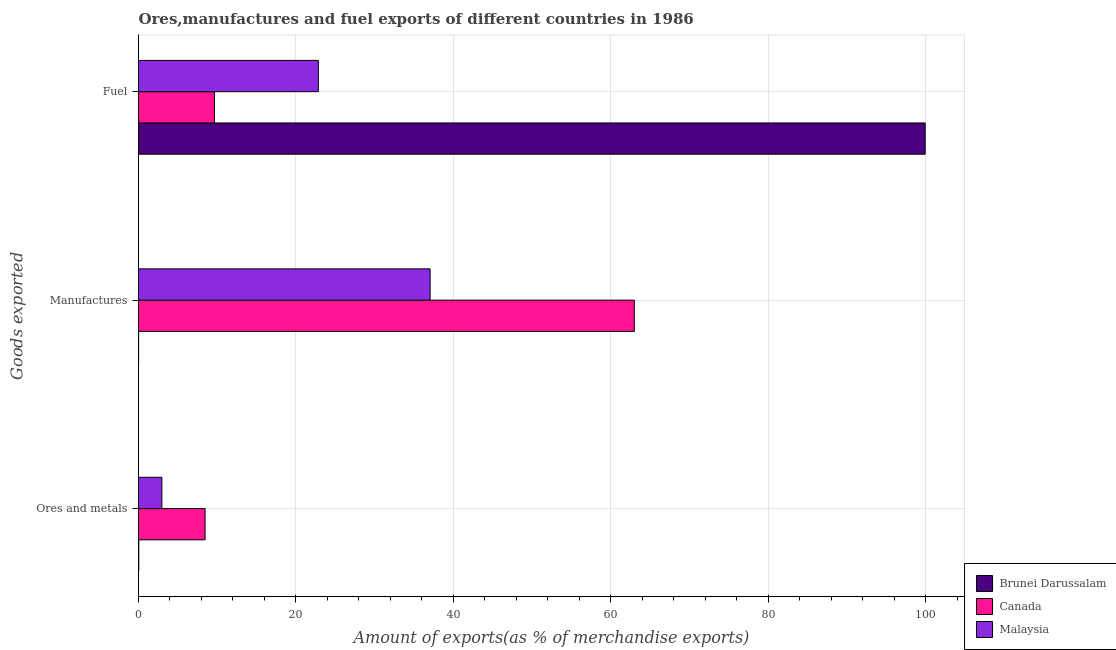How many different coloured bars are there?
Provide a short and direct response. 3. How many groups of bars are there?
Your answer should be very brief. 3. Are the number of bars on each tick of the Y-axis equal?
Your response must be concise. Yes. How many bars are there on the 1st tick from the bottom?
Provide a short and direct response. 3. What is the label of the 1st group of bars from the top?
Give a very brief answer. Fuel. What is the percentage of manufactures exports in Malaysia?
Your answer should be compact. 37.05. Across all countries, what is the maximum percentage of fuel exports?
Ensure brevity in your answer.  99.95. Across all countries, what is the minimum percentage of manufactures exports?
Make the answer very short. 0.01. In which country was the percentage of manufactures exports minimum?
Give a very brief answer. Brunei Darussalam. What is the total percentage of ores and metals exports in the graph?
Offer a very short reply. 11.46. What is the difference between the percentage of fuel exports in Brunei Darussalam and that in Canada?
Provide a short and direct response. 90.29. What is the difference between the percentage of manufactures exports in Canada and the percentage of fuel exports in Brunei Darussalam?
Ensure brevity in your answer.  -36.95. What is the average percentage of fuel exports per country?
Provide a succinct answer. 44.15. What is the difference between the percentage of fuel exports and percentage of manufactures exports in Brunei Darussalam?
Your answer should be compact. 99.93. In how many countries, is the percentage of manufactures exports greater than 88 %?
Keep it short and to the point. 0. What is the ratio of the percentage of manufactures exports in Brunei Darussalam to that in Canada?
Your response must be concise. 0. Is the percentage of fuel exports in Malaysia less than that in Canada?
Make the answer very short. No. Is the difference between the percentage of manufactures exports in Brunei Darussalam and Malaysia greater than the difference between the percentage of fuel exports in Brunei Darussalam and Malaysia?
Make the answer very short. No. What is the difference between the highest and the second highest percentage of fuel exports?
Offer a very short reply. 77.1. What is the difference between the highest and the lowest percentage of ores and metals exports?
Provide a short and direct response. 8.42. In how many countries, is the percentage of fuel exports greater than the average percentage of fuel exports taken over all countries?
Provide a succinct answer. 1. What does the 3rd bar from the bottom in Ores and metals represents?
Offer a very short reply. Malaysia. How many bars are there?
Ensure brevity in your answer.  9. How many countries are there in the graph?
Ensure brevity in your answer.  3. What is the difference between two consecutive major ticks on the X-axis?
Your response must be concise. 20. Where does the legend appear in the graph?
Your response must be concise. Bottom right. How many legend labels are there?
Provide a succinct answer. 3. How are the legend labels stacked?
Your response must be concise. Vertical. What is the title of the graph?
Provide a succinct answer. Ores,manufactures and fuel exports of different countries in 1986. Does "Hong Kong" appear as one of the legend labels in the graph?
Your answer should be very brief. No. What is the label or title of the X-axis?
Provide a short and direct response. Amount of exports(as % of merchandise exports). What is the label or title of the Y-axis?
Your answer should be very brief. Goods exported. What is the Amount of exports(as % of merchandise exports) of Brunei Darussalam in Ores and metals?
Keep it short and to the point. 0.03. What is the Amount of exports(as % of merchandise exports) of Canada in Ores and metals?
Your answer should be very brief. 8.46. What is the Amount of exports(as % of merchandise exports) in Malaysia in Ores and metals?
Offer a terse response. 2.97. What is the Amount of exports(as % of merchandise exports) in Brunei Darussalam in Manufactures?
Offer a very short reply. 0.01. What is the Amount of exports(as % of merchandise exports) in Canada in Manufactures?
Your response must be concise. 62.99. What is the Amount of exports(as % of merchandise exports) in Malaysia in Manufactures?
Your answer should be compact. 37.05. What is the Amount of exports(as % of merchandise exports) in Brunei Darussalam in Fuel?
Give a very brief answer. 99.95. What is the Amount of exports(as % of merchandise exports) of Canada in Fuel?
Your response must be concise. 9.65. What is the Amount of exports(as % of merchandise exports) of Malaysia in Fuel?
Offer a terse response. 22.85. Across all Goods exported, what is the maximum Amount of exports(as % of merchandise exports) in Brunei Darussalam?
Offer a terse response. 99.95. Across all Goods exported, what is the maximum Amount of exports(as % of merchandise exports) of Canada?
Ensure brevity in your answer.  62.99. Across all Goods exported, what is the maximum Amount of exports(as % of merchandise exports) of Malaysia?
Offer a very short reply. 37.05. Across all Goods exported, what is the minimum Amount of exports(as % of merchandise exports) in Brunei Darussalam?
Provide a short and direct response. 0.01. Across all Goods exported, what is the minimum Amount of exports(as % of merchandise exports) in Canada?
Offer a terse response. 8.46. Across all Goods exported, what is the minimum Amount of exports(as % of merchandise exports) of Malaysia?
Provide a succinct answer. 2.97. What is the total Amount of exports(as % of merchandise exports) of Brunei Darussalam in the graph?
Your answer should be compact. 99.99. What is the total Amount of exports(as % of merchandise exports) of Canada in the graph?
Offer a very short reply. 81.1. What is the total Amount of exports(as % of merchandise exports) of Malaysia in the graph?
Offer a terse response. 62.87. What is the difference between the Amount of exports(as % of merchandise exports) of Brunei Darussalam in Ores and metals and that in Manufactures?
Ensure brevity in your answer.  0.02. What is the difference between the Amount of exports(as % of merchandise exports) in Canada in Ores and metals and that in Manufactures?
Give a very brief answer. -54.53. What is the difference between the Amount of exports(as % of merchandise exports) of Malaysia in Ores and metals and that in Manufactures?
Provide a succinct answer. -34.08. What is the difference between the Amount of exports(as % of merchandise exports) of Brunei Darussalam in Ores and metals and that in Fuel?
Offer a very short reply. -99.91. What is the difference between the Amount of exports(as % of merchandise exports) in Canada in Ores and metals and that in Fuel?
Offer a very short reply. -1.2. What is the difference between the Amount of exports(as % of merchandise exports) in Malaysia in Ores and metals and that in Fuel?
Ensure brevity in your answer.  -19.88. What is the difference between the Amount of exports(as % of merchandise exports) in Brunei Darussalam in Manufactures and that in Fuel?
Your answer should be very brief. -99.93. What is the difference between the Amount of exports(as % of merchandise exports) in Canada in Manufactures and that in Fuel?
Give a very brief answer. 53.34. What is the difference between the Amount of exports(as % of merchandise exports) of Malaysia in Manufactures and that in Fuel?
Your answer should be compact. 14.2. What is the difference between the Amount of exports(as % of merchandise exports) of Brunei Darussalam in Ores and metals and the Amount of exports(as % of merchandise exports) of Canada in Manufactures?
Provide a short and direct response. -62.96. What is the difference between the Amount of exports(as % of merchandise exports) in Brunei Darussalam in Ores and metals and the Amount of exports(as % of merchandise exports) in Malaysia in Manufactures?
Offer a terse response. -37.01. What is the difference between the Amount of exports(as % of merchandise exports) of Canada in Ores and metals and the Amount of exports(as % of merchandise exports) of Malaysia in Manufactures?
Your answer should be compact. -28.59. What is the difference between the Amount of exports(as % of merchandise exports) of Brunei Darussalam in Ores and metals and the Amount of exports(as % of merchandise exports) of Canada in Fuel?
Provide a short and direct response. -9.62. What is the difference between the Amount of exports(as % of merchandise exports) of Brunei Darussalam in Ores and metals and the Amount of exports(as % of merchandise exports) of Malaysia in Fuel?
Ensure brevity in your answer.  -22.82. What is the difference between the Amount of exports(as % of merchandise exports) in Canada in Ores and metals and the Amount of exports(as % of merchandise exports) in Malaysia in Fuel?
Your answer should be very brief. -14.39. What is the difference between the Amount of exports(as % of merchandise exports) of Brunei Darussalam in Manufactures and the Amount of exports(as % of merchandise exports) of Canada in Fuel?
Provide a succinct answer. -9.64. What is the difference between the Amount of exports(as % of merchandise exports) in Brunei Darussalam in Manufactures and the Amount of exports(as % of merchandise exports) in Malaysia in Fuel?
Ensure brevity in your answer.  -22.84. What is the difference between the Amount of exports(as % of merchandise exports) of Canada in Manufactures and the Amount of exports(as % of merchandise exports) of Malaysia in Fuel?
Make the answer very short. 40.14. What is the average Amount of exports(as % of merchandise exports) in Brunei Darussalam per Goods exported?
Your answer should be very brief. 33.33. What is the average Amount of exports(as % of merchandise exports) of Canada per Goods exported?
Your answer should be very brief. 27.03. What is the average Amount of exports(as % of merchandise exports) in Malaysia per Goods exported?
Your response must be concise. 20.96. What is the difference between the Amount of exports(as % of merchandise exports) of Brunei Darussalam and Amount of exports(as % of merchandise exports) of Canada in Ores and metals?
Ensure brevity in your answer.  -8.42. What is the difference between the Amount of exports(as % of merchandise exports) in Brunei Darussalam and Amount of exports(as % of merchandise exports) in Malaysia in Ores and metals?
Ensure brevity in your answer.  -2.93. What is the difference between the Amount of exports(as % of merchandise exports) in Canada and Amount of exports(as % of merchandise exports) in Malaysia in Ores and metals?
Ensure brevity in your answer.  5.49. What is the difference between the Amount of exports(as % of merchandise exports) of Brunei Darussalam and Amount of exports(as % of merchandise exports) of Canada in Manufactures?
Your answer should be very brief. -62.98. What is the difference between the Amount of exports(as % of merchandise exports) of Brunei Darussalam and Amount of exports(as % of merchandise exports) of Malaysia in Manufactures?
Provide a short and direct response. -37.04. What is the difference between the Amount of exports(as % of merchandise exports) in Canada and Amount of exports(as % of merchandise exports) in Malaysia in Manufactures?
Make the answer very short. 25.94. What is the difference between the Amount of exports(as % of merchandise exports) of Brunei Darussalam and Amount of exports(as % of merchandise exports) of Canada in Fuel?
Make the answer very short. 90.29. What is the difference between the Amount of exports(as % of merchandise exports) in Brunei Darussalam and Amount of exports(as % of merchandise exports) in Malaysia in Fuel?
Offer a very short reply. 77.1. What is the difference between the Amount of exports(as % of merchandise exports) in Canada and Amount of exports(as % of merchandise exports) in Malaysia in Fuel?
Your response must be concise. -13.2. What is the ratio of the Amount of exports(as % of merchandise exports) of Brunei Darussalam in Ores and metals to that in Manufactures?
Offer a very short reply. 2.74. What is the ratio of the Amount of exports(as % of merchandise exports) in Canada in Ores and metals to that in Manufactures?
Keep it short and to the point. 0.13. What is the ratio of the Amount of exports(as % of merchandise exports) of Malaysia in Ores and metals to that in Manufactures?
Provide a succinct answer. 0.08. What is the ratio of the Amount of exports(as % of merchandise exports) of Canada in Ores and metals to that in Fuel?
Provide a short and direct response. 0.88. What is the ratio of the Amount of exports(as % of merchandise exports) of Malaysia in Ores and metals to that in Fuel?
Offer a very short reply. 0.13. What is the ratio of the Amount of exports(as % of merchandise exports) in Brunei Darussalam in Manufactures to that in Fuel?
Your answer should be compact. 0. What is the ratio of the Amount of exports(as % of merchandise exports) of Canada in Manufactures to that in Fuel?
Offer a terse response. 6.53. What is the ratio of the Amount of exports(as % of merchandise exports) of Malaysia in Manufactures to that in Fuel?
Your response must be concise. 1.62. What is the difference between the highest and the second highest Amount of exports(as % of merchandise exports) in Brunei Darussalam?
Ensure brevity in your answer.  99.91. What is the difference between the highest and the second highest Amount of exports(as % of merchandise exports) in Canada?
Your response must be concise. 53.34. What is the difference between the highest and the second highest Amount of exports(as % of merchandise exports) of Malaysia?
Offer a very short reply. 14.2. What is the difference between the highest and the lowest Amount of exports(as % of merchandise exports) in Brunei Darussalam?
Ensure brevity in your answer.  99.93. What is the difference between the highest and the lowest Amount of exports(as % of merchandise exports) of Canada?
Your response must be concise. 54.53. What is the difference between the highest and the lowest Amount of exports(as % of merchandise exports) of Malaysia?
Keep it short and to the point. 34.08. 